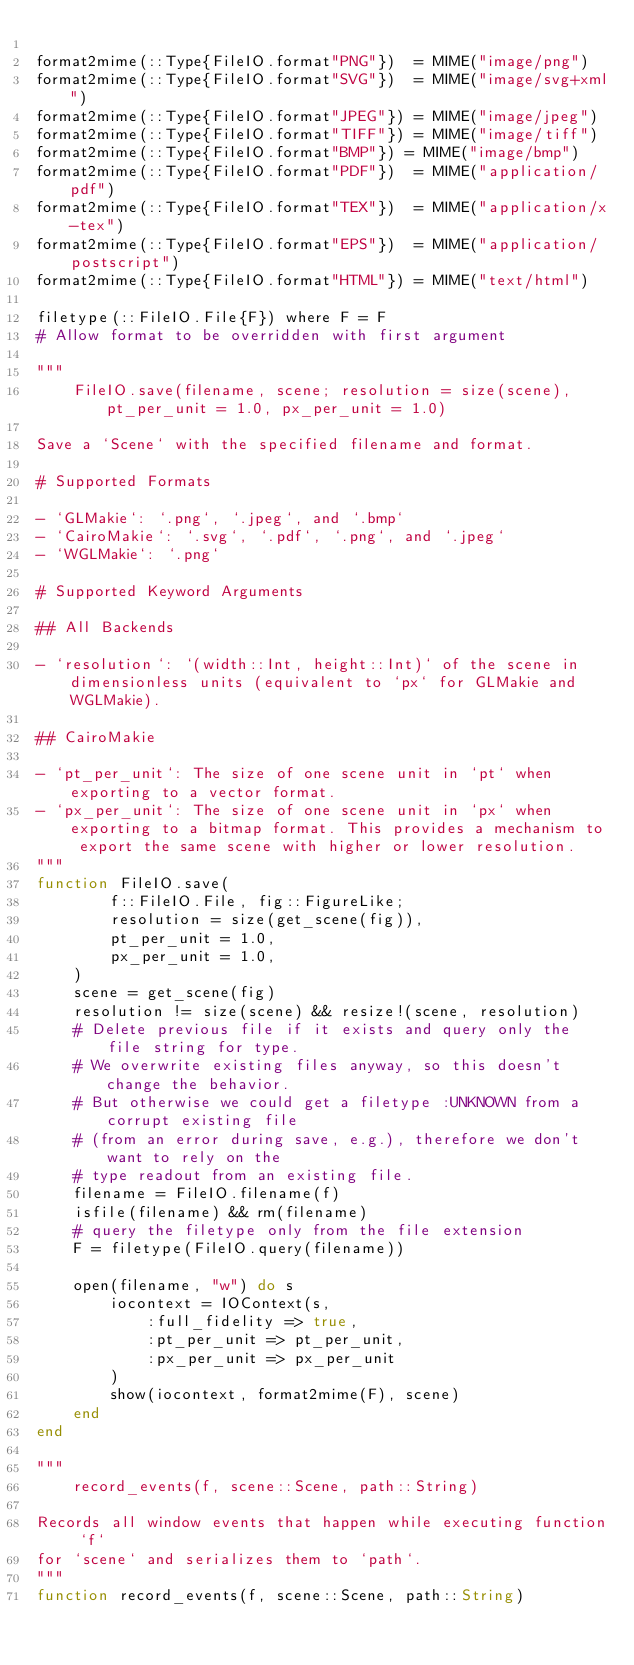Convert code to text. <code><loc_0><loc_0><loc_500><loc_500><_Julia_>
format2mime(::Type{FileIO.format"PNG"})  = MIME("image/png")
format2mime(::Type{FileIO.format"SVG"})  = MIME("image/svg+xml")
format2mime(::Type{FileIO.format"JPEG"}) = MIME("image/jpeg")
format2mime(::Type{FileIO.format"TIFF"}) = MIME("image/tiff")
format2mime(::Type{FileIO.format"BMP"}) = MIME("image/bmp")
format2mime(::Type{FileIO.format"PDF"})  = MIME("application/pdf")
format2mime(::Type{FileIO.format"TEX"})  = MIME("application/x-tex")
format2mime(::Type{FileIO.format"EPS"})  = MIME("application/postscript")
format2mime(::Type{FileIO.format"HTML"}) = MIME("text/html")

filetype(::FileIO.File{F}) where F = F
# Allow format to be overridden with first argument

"""
    FileIO.save(filename, scene; resolution = size(scene), pt_per_unit = 1.0, px_per_unit = 1.0)

Save a `Scene` with the specified filename and format.

# Supported Formats

- `GLMakie`: `.png`, `.jpeg`, and `.bmp`
- `CairoMakie`: `.svg`, `.pdf`, `.png`, and `.jpeg`
- `WGLMakie`: `.png`

# Supported Keyword Arguments

## All Backends

- `resolution`: `(width::Int, height::Int)` of the scene in dimensionless units (equivalent to `px` for GLMakie and WGLMakie).

## CairoMakie

- `pt_per_unit`: The size of one scene unit in `pt` when exporting to a vector format.
- `px_per_unit`: The size of one scene unit in `px` when exporting to a bitmap format. This provides a mechanism to export the same scene with higher or lower resolution.
"""
function FileIO.save(
        f::FileIO.File, fig::FigureLike;
        resolution = size(get_scene(fig)),
        pt_per_unit = 1.0,
        px_per_unit = 1.0,
    )
    scene = get_scene(fig)
    resolution != size(scene) && resize!(scene, resolution)
    # Delete previous file if it exists and query only the file string for type.
    # We overwrite existing files anyway, so this doesn't change the behavior.
    # But otherwise we could get a filetype :UNKNOWN from a corrupt existing file
    # (from an error during save, e.g.), therefore we don't want to rely on the
    # type readout from an existing file.
    filename = FileIO.filename(f)
    isfile(filename) && rm(filename)
    # query the filetype only from the file extension
    F = filetype(FileIO.query(filename))

    open(filename, "w") do s
        iocontext = IOContext(s,
            :full_fidelity => true,
            :pt_per_unit => pt_per_unit,
            :px_per_unit => px_per_unit
        )
        show(iocontext, format2mime(F), scene)
    end
end

"""
    record_events(f, scene::Scene, path::String)

Records all window events that happen while executing function `f`
for `scene` and serializes them to `path`.
"""
function record_events(f, scene::Scene, path::String)</code> 